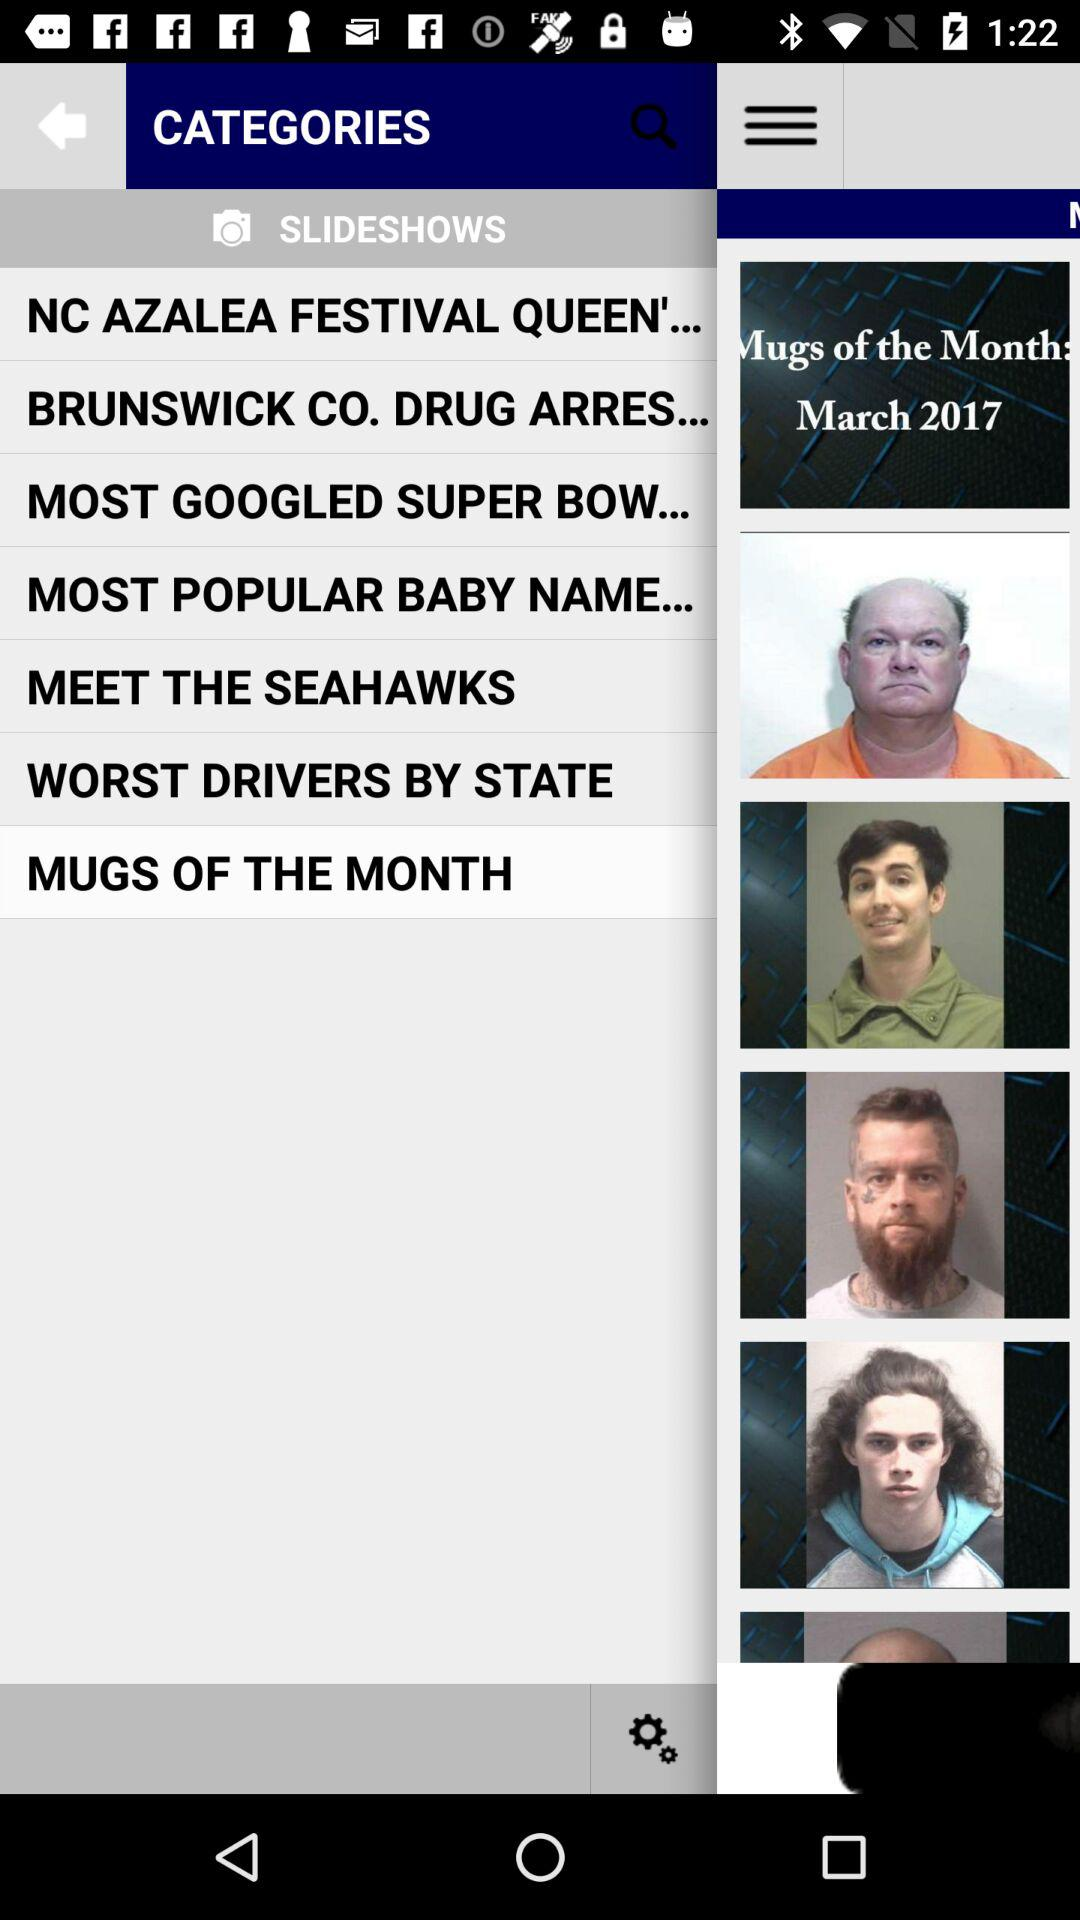For what month are the "Mugs of the Month"? The "Mugs of the Month" are for the month of March. 